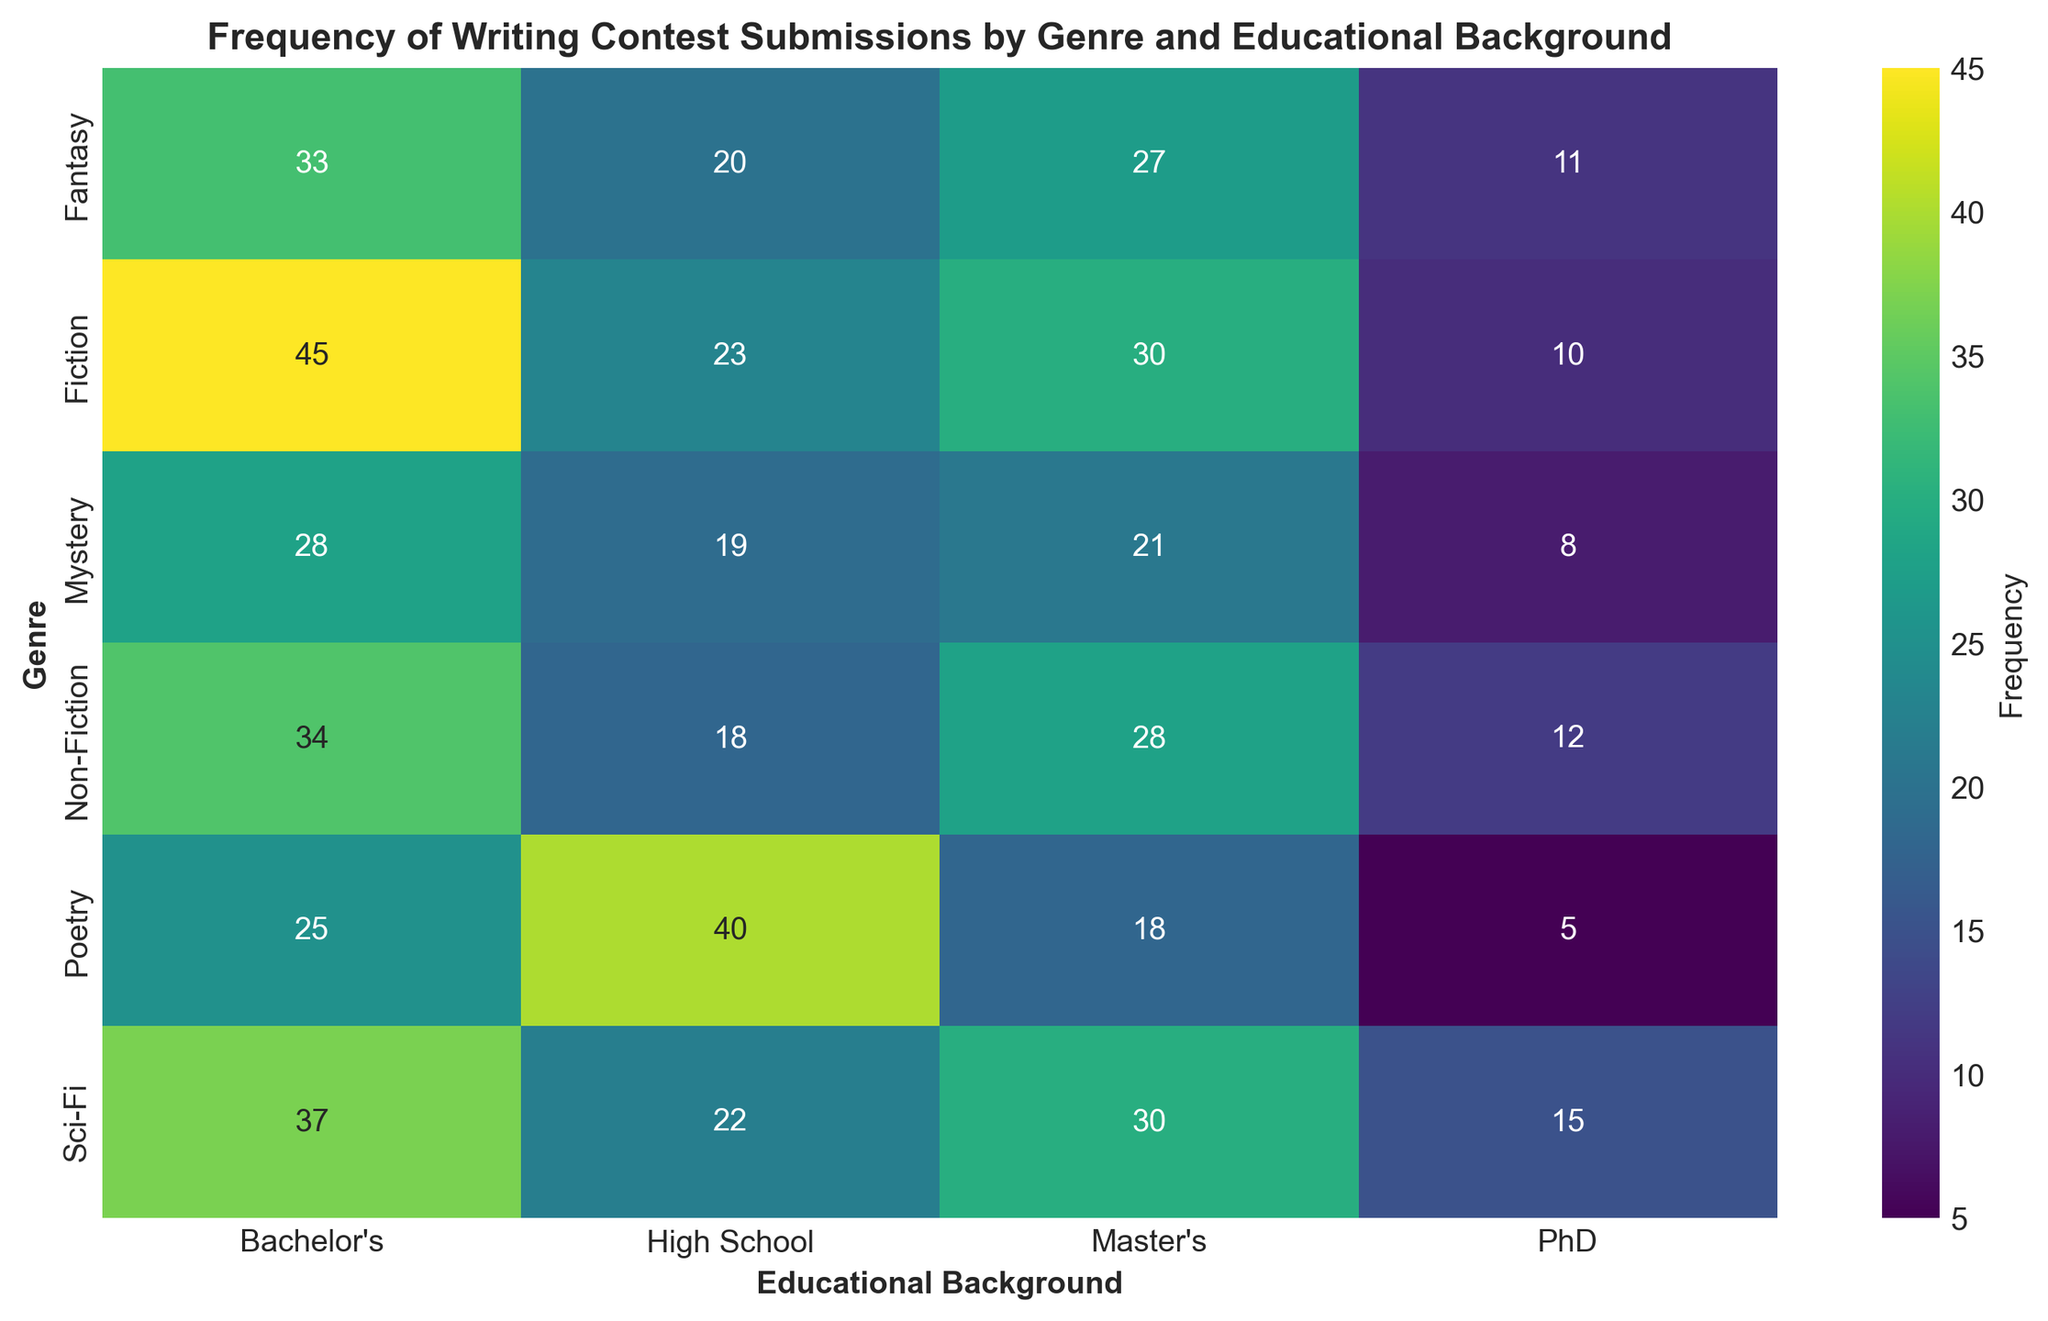What's the most frequently submitted genre among high school participants? First, locate the row for "High School" under the "Educational Background" column. Then, identify the genre with the highest frequency within that column. The "Poetry" genre has a frequency of 40, which is the highest.
Answer: Poetry Which genre sees the least participation from PhD holders? Look at the "PhD" column and identify the smallest number. The smallest number is 5 in the row for "Poetry".
Answer: Poetry Calculate the total number of submissions for the "Sci-Fi" genre across all educational backgrounds. Sum the frequencies for "Sci-Fi" genre across all educational levels: 22 (High School) + 37 (Bachelor's) + 30 (Master's) + 15 (PhD) = 104.
Answer: 104 Compare the frequency of submissions for "Fantasy" and "Mystery" among participants with a Bachelor's degree. Which genre is more popular? Check the frequencies in the "Bachelor's" column for both "Fantasy" and "Mystery". "Fantasy" has 33 while "Mystery" has 28. So, "Fantasy" is more popular.
Answer: Fantasy Is there a specific educational background that has a generally higher frequency of submissions across all genres? Examine the sum of frequencies in each educational column. You will see that the "Bachelor's" column has the highest frequencies summed, indicating that participants with a Bachelor's degree submit more frequently across all genres.
Answer: Bachelor's Which educational background has the second highest number of submissions for the genre "Fiction"? Look at the "Fiction" row and check the values under each educational background. The greatest value is 45 for "Bachelor's", followed by 30 for "Master's". Therefore, Master's has the second highest number of submissions for "Fiction".
Answer: Master's On average, how many submissions are there from PhD holders across all genres? First, find the total frequency for the "PhD" column by summing up all genres: 10 (Fiction) + 12 (Non-Fiction) + 5 (Poetry) + 15 (Sci-Fi) + 11 (Fantasy) + 8 (Mystery) = 61. Then divide by the number of genres (6): 61/6 ≈ 10.17.
Answer: 10.17 Which two genres have the closest number of submissions from "Master's" degree holders? Compare the values in the "Master's" column. "Sci-Fi" and "Fiction" have 30 and 30 submissions respectively, which are closest in number.
Answer: Sci-Fi and Fiction How does the frequency of "Poetry" submissions vary by educational background? Observe the "Poetry" row and note the frequencies under each educational background: 40 (High School), 25 (Bachelor's), 18 (Master's), and 5 (PhD). This shows a general decline in submissions as educational level increases.
Answer: Decreases with increasing education 